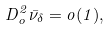Convert formula to latex. <formula><loc_0><loc_0><loc_500><loc_500>D ^ { 2 } _ { o } \bar { \nu } _ { \delta } = o ( 1 ) ,</formula> 